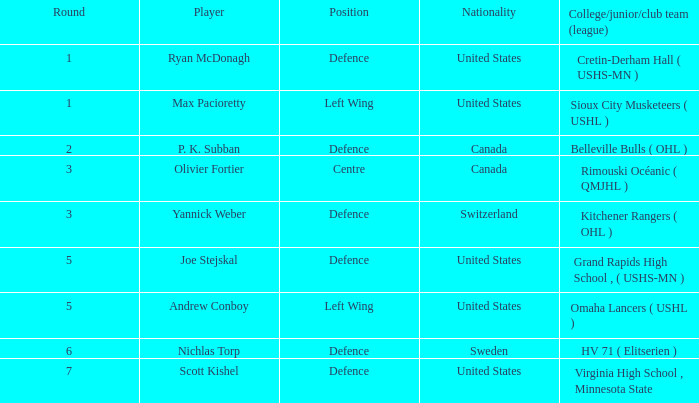Would you be able to parse every entry in this table? {'header': ['Round', 'Player', 'Position', 'Nationality', 'College/junior/club team (league)'], 'rows': [['1', 'Ryan McDonagh', 'Defence', 'United States', 'Cretin-Derham Hall ( USHS-MN )'], ['1', 'Max Pacioretty', 'Left Wing', 'United States', 'Sioux City Musketeers ( USHL )'], ['2', 'P. K. Subban', 'Defence', 'Canada', 'Belleville Bulls ( OHL )'], ['3', 'Olivier Fortier', 'Centre', 'Canada', 'Rimouski Océanic ( QMJHL )'], ['3', 'Yannick Weber', 'Defence', 'Switzerland', 'Kitchener Rangers ( OHL )'], ['5', 'Joe Stejskal', 'Defence', 'United States', 'Grand Rapids High School , ( USHS-MN )'], ['5', 'Andrew Conboy', 'Left Wing', 'United States', 'Omaha Lancers ( USHL )'], ['6', 'Nichlas Torp', 'Defence', 'Sweden', 'HV 71 ( Elitserien )'], ['7', 'Scott Kishel', 'Defence', 'United States', 'Virginia High School , Minnesota State']]} Which player from the United States plays defence and was chosen before round 5? Ryan McDonagh. 